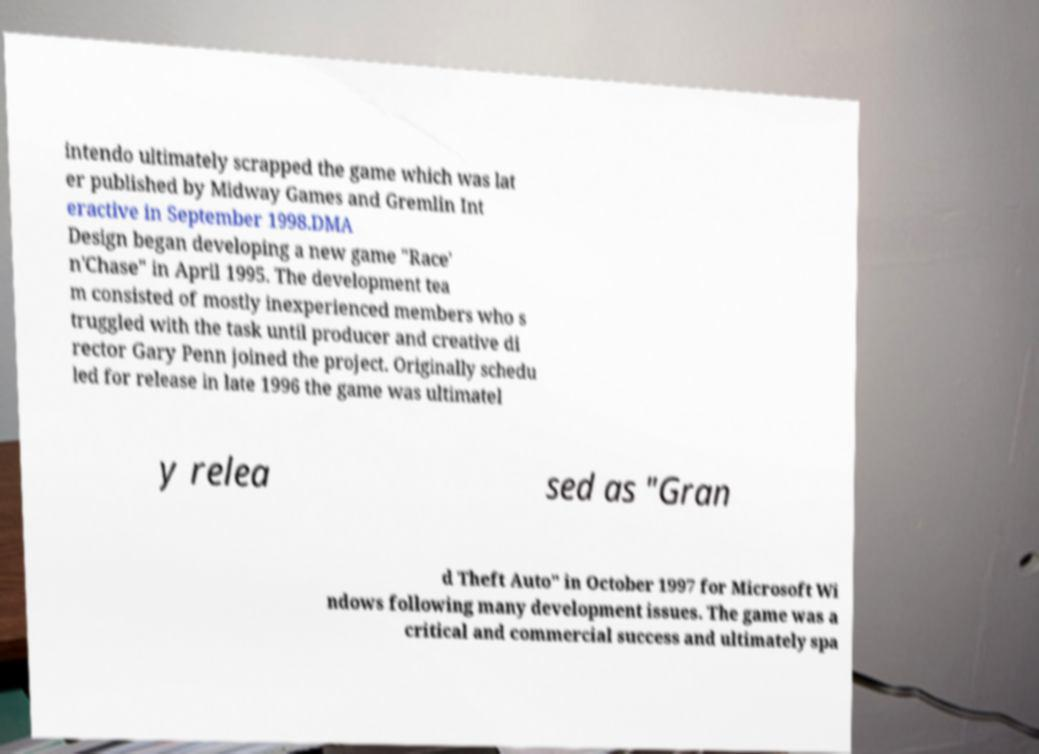Could you extract and type out the text from this image? intendo ultimately scrapped the game which was lat er published by Midway Games and Gremlin Int eractive in September 1998.DMA Design began developing a new game "Race' n'Chase" in April 1995. The development tea m consisted of mostly inexperienced members who s truggled with the task until producer and creative di rector Gary Penn joined the project. Originally schedu led for release in late 1996 the game was ultimatel y relea sed as "Gran d Theft Auto" in October 1997 for Microsoft Wi ndows following many development issues. The game was a critical and commercial success and ultimately spa 